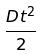Convert formula to latex. <formula><loc_0><loc_0><loc_500><loc_500>\frac { D t ^ { 2 } } { 2 }</formula> 